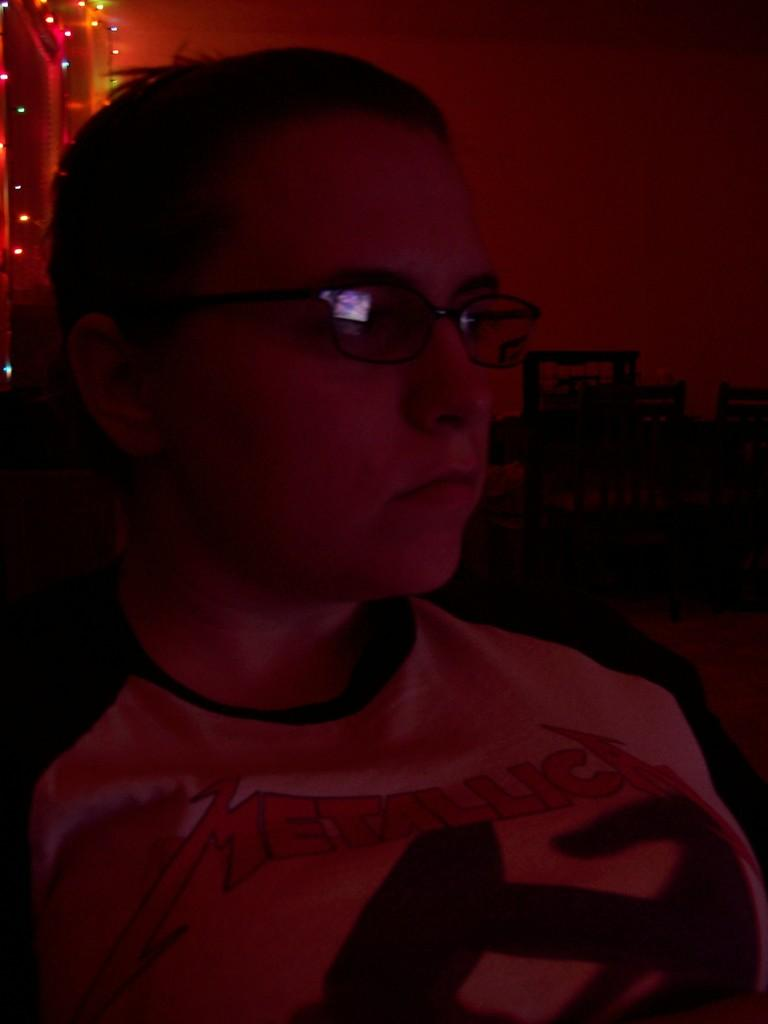What type of living organism is present in the image? There is a human in the image. What can be seen illuminating the scene in the image? There are lights visible in the image. What is in the background of the image? There is a wall in the background of the image. What type of beast is present in the image? There is no beast present in the image; it features a human. What type of learning material can be seen in the image? There is no learning material present in the image. 